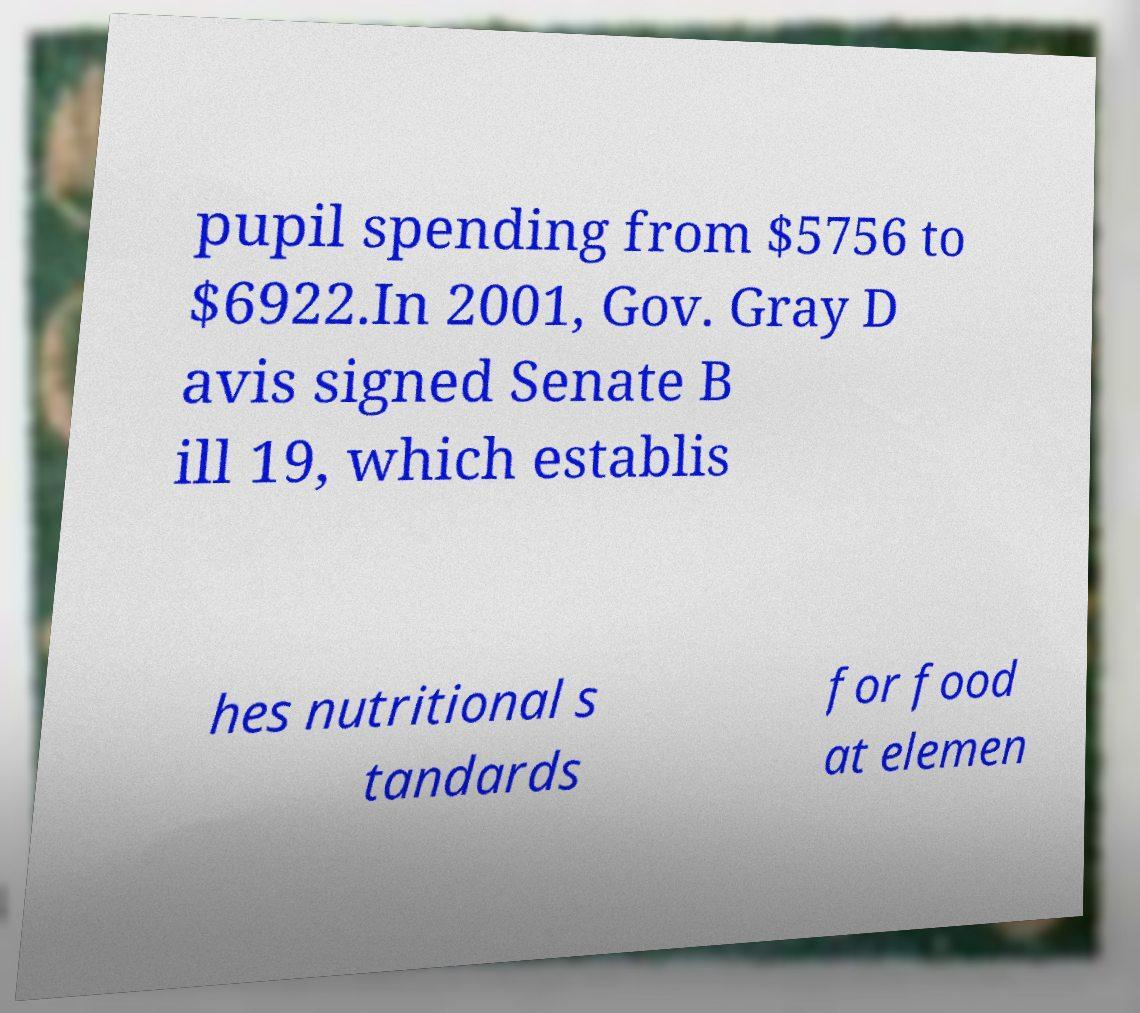I need the written content from this picture converted into text. Can you do that? pupil spending from $5756 to $6922.In 2001, Gov. Gray D avis signed Senate B ill 19, which establis hes nutritional s tandards for food at elemen 